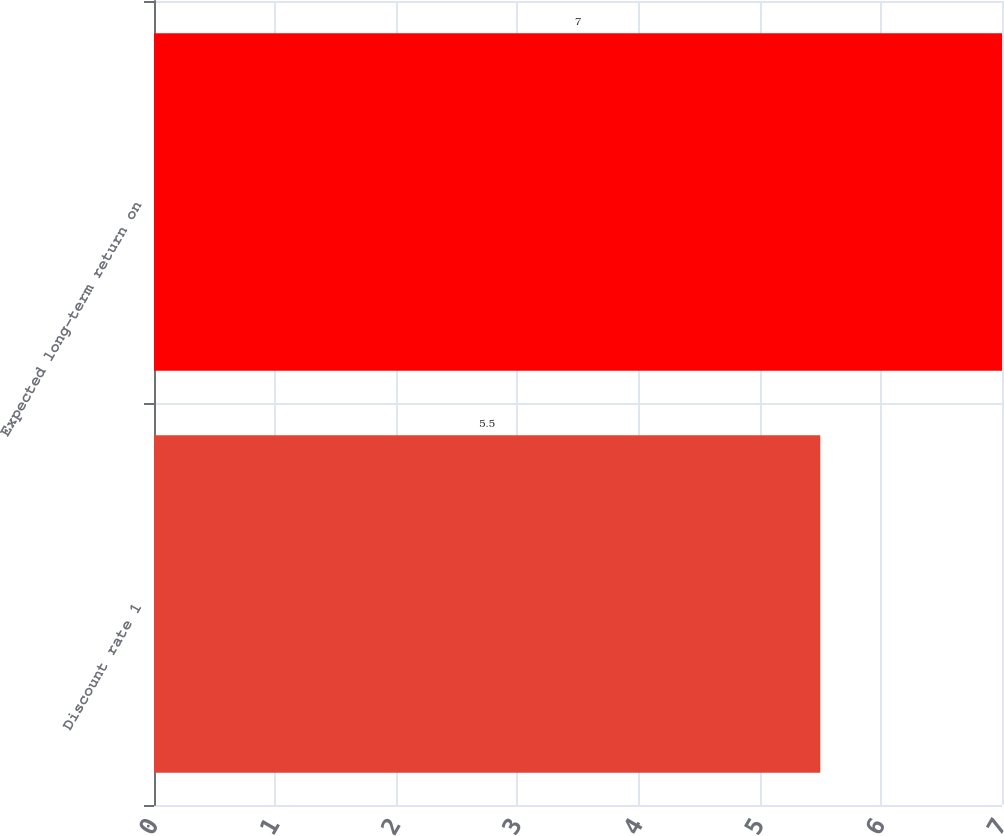Convert chart to OTSL. <chart><loc_0><loc_0><loc_500><loc_500><bar_chart><fcel>Discount rate 1<fcel>Expected long-term return on<nl><fcel>5.5<fcel>7<nl></chart> 